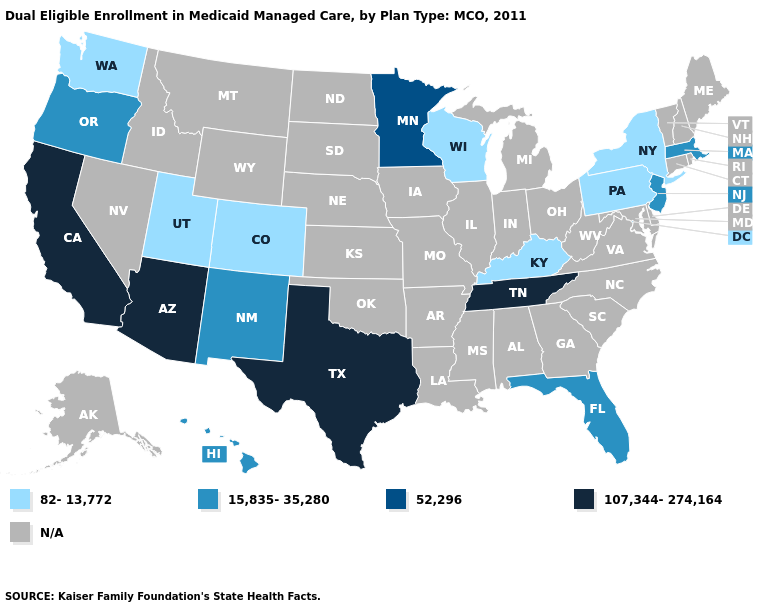Name the states that have a value in the range 107,344-274,164?
Give a very brief answer. Arizona, California, Tennessee, Texas. What is the value of Oregon?
Answer briefly. 15,835-35,280. What is the value of Idaho?
Be succinct. N/A. Name the states that have a value in the range N/A?
Keep it brief. Alabama, Alaska, Arkansas, Connecticut, Delaware, Georgia, Idaho, Illinois, Indiana, Iowa, Kansas, Louisiana, Maine, Maryland, Michigan, Mississippi, Missouri, Montana, Nebraska, Nevada, New Hampshire, North Carolina, North Dakota, Ohio, Oklahoma, Rhode Island, South Carolina, South Dakota, Vermont, Virginia, West Virginia, Wyoming. Which states have the lowest value in the USA?
Short answer required. Colorado, Kentucky, New York, Pennsylvania, Utah, Washington, Wisconsin. What is the lowest value in the USA?
Be succinct. 82-13,772. Name the states that have a value in the range 52,296?
Answer briefly. Minnesota. Name the states that have a value in the range 52,296?
Short answer required. Minnesota. What is the value of California?
Concise answer only. 107,344-274,164. What is the value of Texas?
Answer briefly. 107,344-274,164. Does California have the highest value in the USA?
Give a very brief answer. Yes. What is the value of Washington?
Answer briefly. 82-13,772. Does Texas have the highest value in the USA?
Short answer required. Yes. How many symbols are there in the legend?
Quick response, please. 5. What is the highest value in states that border Indiana?
Be succinct. 82-13,772. 